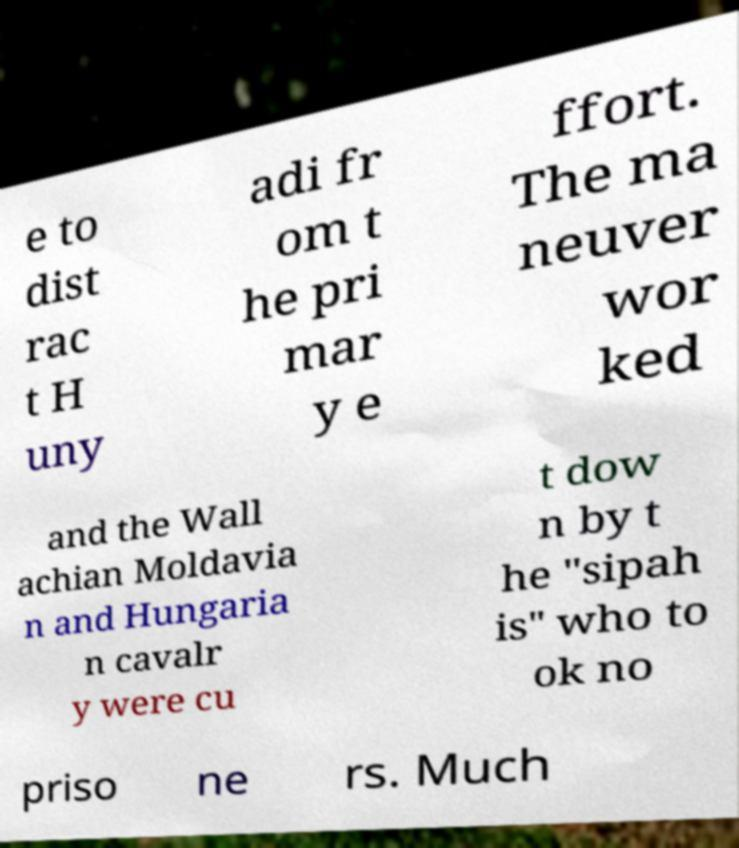Could you extract and type out the text from this image? e to dist rac t H uny adi fr om t he pri mar y e ffort. The ma neuver wor ked and the Wall achian Moldavia n and Hungaria n cavalr y were cu t dow n by t he "sipah is" who to ok no priso ne rs. Much 